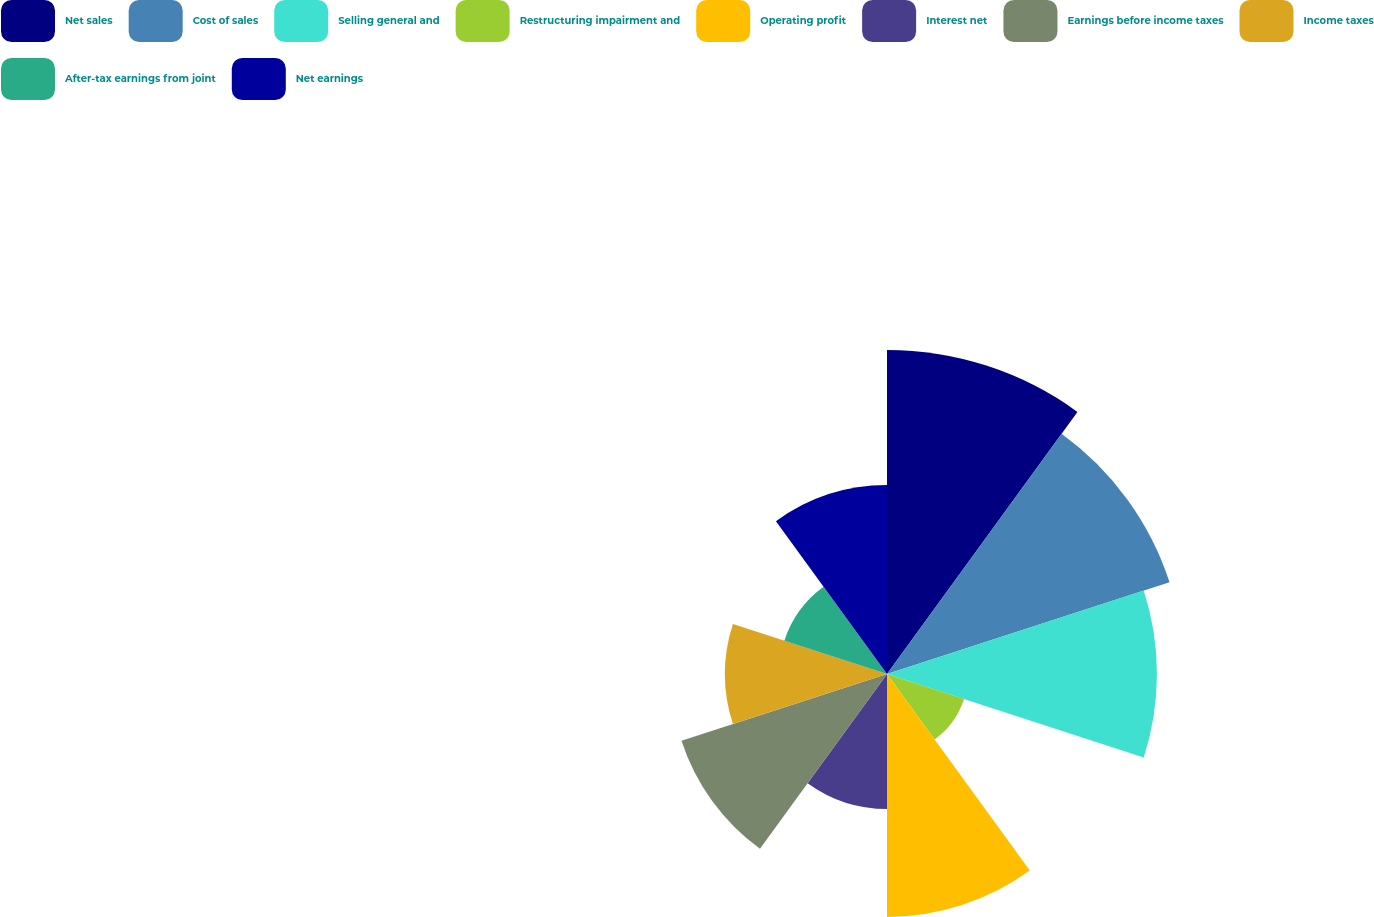Convert chart. <chart><loc_0><loc_0><loc_500><loc_500><pie_chart><fcel>Net sales<fcel>Cost of sales<fcel>Selling general and<fcel>Restructuring impairment and<fcel>Operating profit<fcel>Interest net<fcel>Earnings before income taxes<fcel>Income taxes<fcel>After-tax earnings from joint<fcel>Net earnings<nl><fcel>16.0%<fcel>14.67%<fcel>13.33%<fcel>4.0%<fcel>12.0%<fcel>6.67%<fcel>10.67%<fcel>8.0%<fcel>5.33%<fcel>9.33%<nl></chart> 